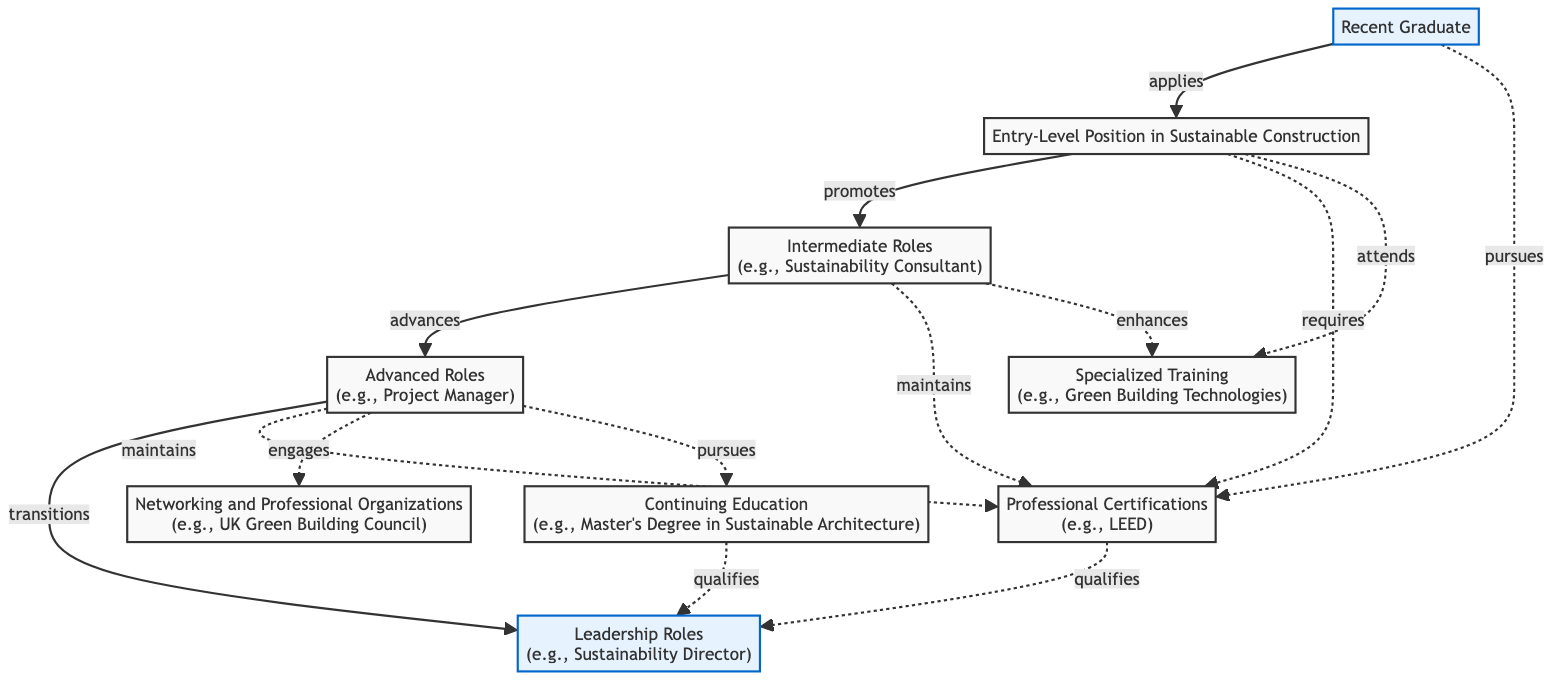What is the first step for a recent graduate in sustainable construction? The diagram indicates that a recent graduate applies for an entry-level position in sustainable construction, making this the first step in their career progression.
Answer: Entry-Level Position in Sustainable Construction How many nodes are there in the diagram? By counting the labeled nodes in the diagram, we see there are nine unique roles or activities related to career progression in sustainable construction.
Answer: 9 What role directly transitions to a leadership position? According to the edges in the diagram, the advanced role, such as Project Manager, transitions to the leadership role of Sustainability Director.
Answer: Advanced Roles What is required to obtain the leadership role? The diagram shows that professional certifications like LEED qualify an individual for the leadership role, indicating that these certifications are necessary to move into that position.
Answer: Professional Certifications What does a recent graduate pursue to enhance their skills? From the diagram, it can be observed that a recent graduate pursues professional certifications and possibly engages in specialized training as preliminary steps to enhance their skills in sustainable construction.
Answer: Professional Certifications, Specialized Training What role promotes to intermediate roles? The edge labeled 'promotes' connects the entry-level position in sustainable construction to intermediate roles, indicating that growth from one to the other happens directly from this initial position.
Answer: Intermediate Roles Which position requires professional certifications? The diagram illustrates that both the entry-level position and the intermediate roles maintain a connection to professional certifications, requiring these credentials to progress further.
Answer: Entry-Level Position, Intermediate Roles What is the total number of edges in the diagram? By counting all connections (edges) between the nodes in the diagram, we find there are twelve unique paths which illustrate the relationships between different career steps, certifications, and training.
Answer: 12 What connection exists between continuing education and leadership roles? Continuing education, specifically a master's degree in sustainable architecture, qualifies an individual for a leadership role in sustainable construction, as shown in the diagram.
Answer: qualifies 